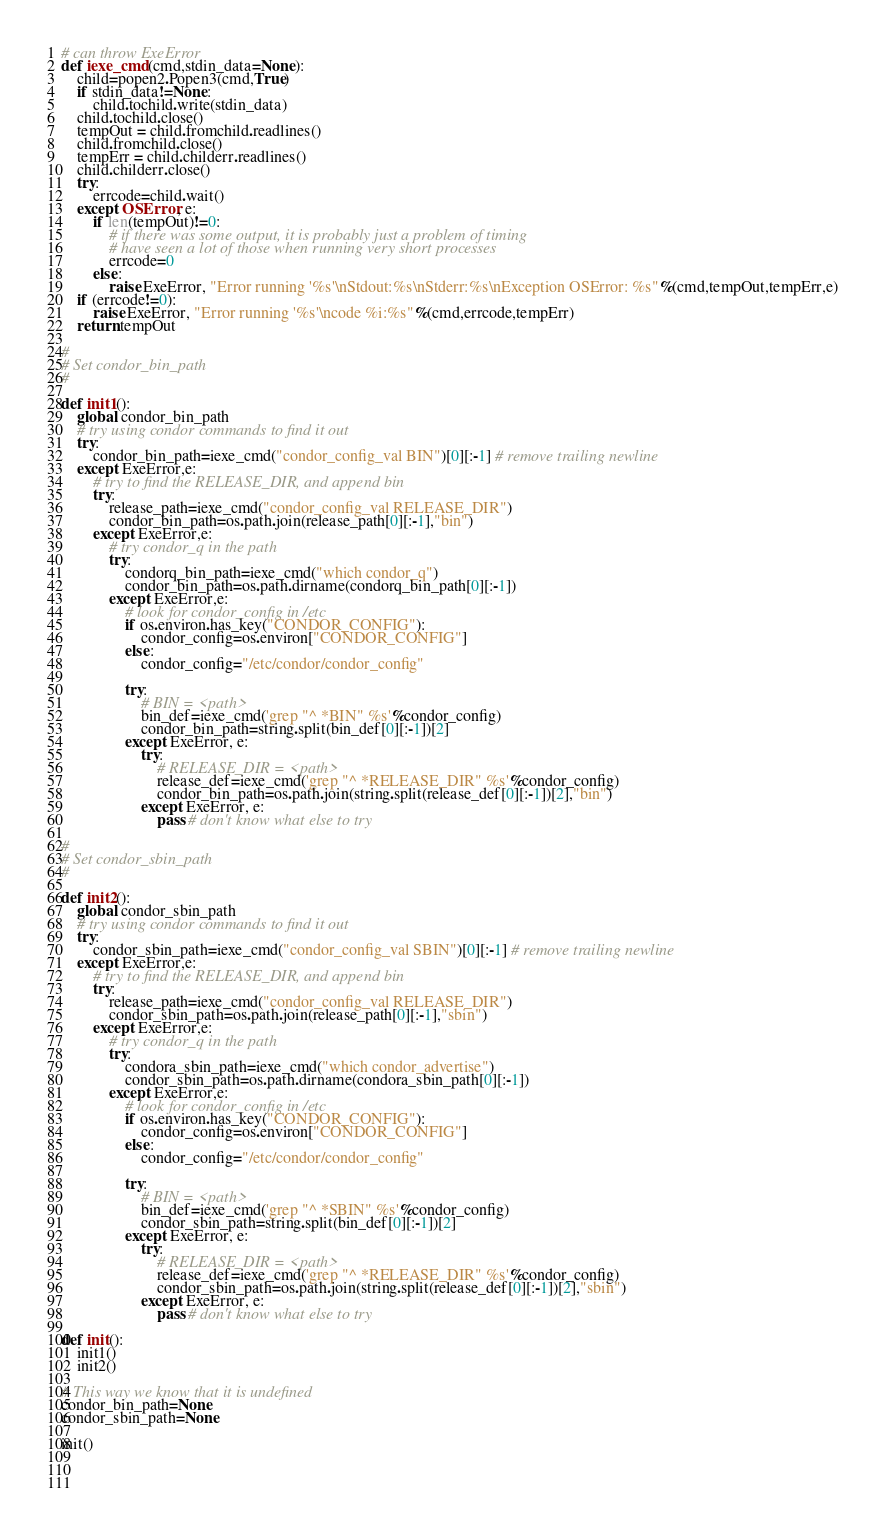Convert code to text. <code><loc_0><loc_0><loc_500><loc_500><_Python_>
# can throw ExeError
def iexe_cmd(cmd,stdin_data=None):
    child=popen2.Popen3(cmd,True)
    if stdin_data!=None:
        child.tochild.write(stdin_data)
    child.tochild.close()
    tempOut = child.fromchild.readlines()
    child.fromchild.close()
    tempErr = child.childerr.readlines()
    child.childerr.close()
    try:
        errcode=child.wait()
    except OSError, e:
        if len(tempOut)!=0:
            # if there was some output, it is probably just a problem of timing
            # have seen a lot of those when running very short processes
            errcode=0
        else:
            raise ExeError, "Error running '%s'\nStdout:%s\nStderr:%s\nException OSError: %s"%(cmd,tempOut,tempErr,e)
    if (errcode!=0):
        raise ExeError, "Error running '%s'\ncode %i:%s"%(cmd,errcode,tempErr)
    return tempOut

#
# Set condor_bin_path
#

def init1():
    global condor_bin_path
    # try using condor commands to find it out
    try:
        condor_bin_path=iexe_cmd("condor_config_val BIN")[0][:-1] # remove trailing newline
    except ExeError,e:
        # try to find the RELEASE_DIR, and append bin
        try:
            release_path=iexe_cmd("condor_config_val RELEASE_DIR")
            condor_bin_path=os.path.join(release_path[0][:-1],"bin")
        except ExeError,e:
            # try condor_q in the path
            try:
                condorq_bin_path=iexe_cmd("which condor_q")
                condor_bin_path=os.path.dirname(condorq_bin_path[0][:-1])
            except ExeError,e:
                # look for condor_config in /etc
                if os.environ.has_key("CONDOR_CONFIG"):
                    condor_config=os.environ["CONDOR_CONFIG"]
                else:
                    condor_config="/etc/condor/condor_config"
                
                try:
                    # BIN = <path>
                    bin_def=iexe_cmd('grep "^ *BIN" %s'%condor_config)
                    condor_bin_path=string.split(bin_def[0][:-1])[2]
                except ExeError, e:
                    try:
                        # RELEASE_DIR = <path>
                        release_def=iexe_cmd('grep "^ *RELEASE_DIR" %s'%condor_config)
                        condor_bin_path=os.path.join(string.split(release_def[0][:-1])[2],"bin")
                    except ExeError, e:
                        pass # don't know what else to try

#
# Set condor_sbin_path
#

def init2():
    global condor_sbin_path
    # try using condor commands to find it out
    try:
        condor_sbin_path=iexe_cmd("condor_config_val SBIN")[0][:-1] # remove trailing newline
    except ExeError,e:
        # try to find the RELEASE_DIR, and append bin
        try:
            release_path=iexe_cmd("condor_config_val RELEASE_DIR")
            condor_sbin_path=os.path.join(release_path[0][:-1],"sbin")
        except ExeError,e:
            # try condor_q in the path
            try:
                condora_sbin_path=iexe_cmd("which condor_advertise")
                condor_sbin_path=os.path.dirname(condora_sbin_path[0][:-1])
            except ExeError,e:
                # look for condor_config in /etc
                if os.environ.has_key("CONDOR_CONFIG"):
                    condor_config=os.environ["CONDOR_CONFIG"]
                else:
                    condor_config="/etc/condor/condor_config"
                
                try:
                    # BIN = <path>
                    bin_def=iexe_cmd('grep "^ *SBIN" %s'%condor_config)
                    condor_sbin_path=string.split(bin_def[0][:-1])[2]
                except ExeError, e:
                    try:
                        # RELEASE_DIR = <path>
                        release_def=iexe_cmd('grep "^ *RELEASE_DIR" %s'%condor_config)
                        condor_sbin_path=os.path.join(string.split(release_def[0][:-1])[2],"sbin")
                    except ExeError, e:
                        pass # don't know what else to try

def init():
    init1()
    init2()

# This way we know that it is undefined
condor_bin_path=None
condor_sbin_path=None

init()


    
</code> 